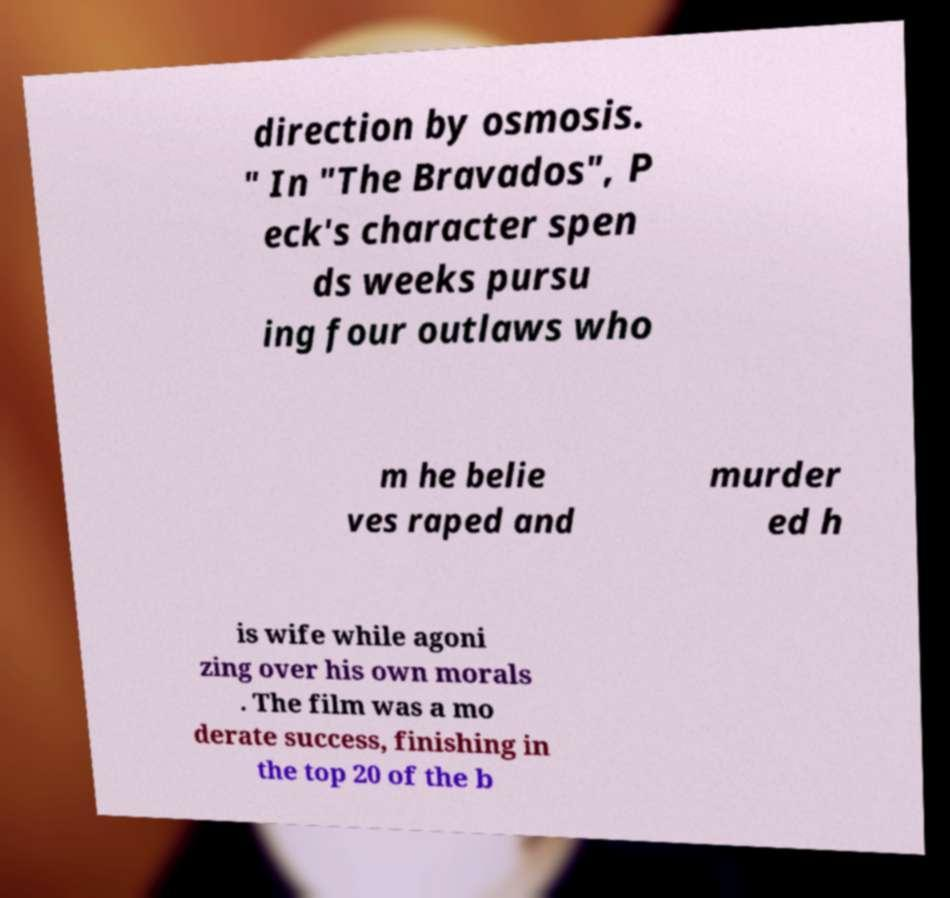For documentation purposes, I need the text within this image transcribed. Could you provide that? direction by osmosis. " In "The Bravados", P eck's character spen ds weeks pursu ing four outlaws who m he belie ves raped and murder ed h is wife while agoni zing over his own morals . The film was a mo derate success, finishing in the top 20 of the b 